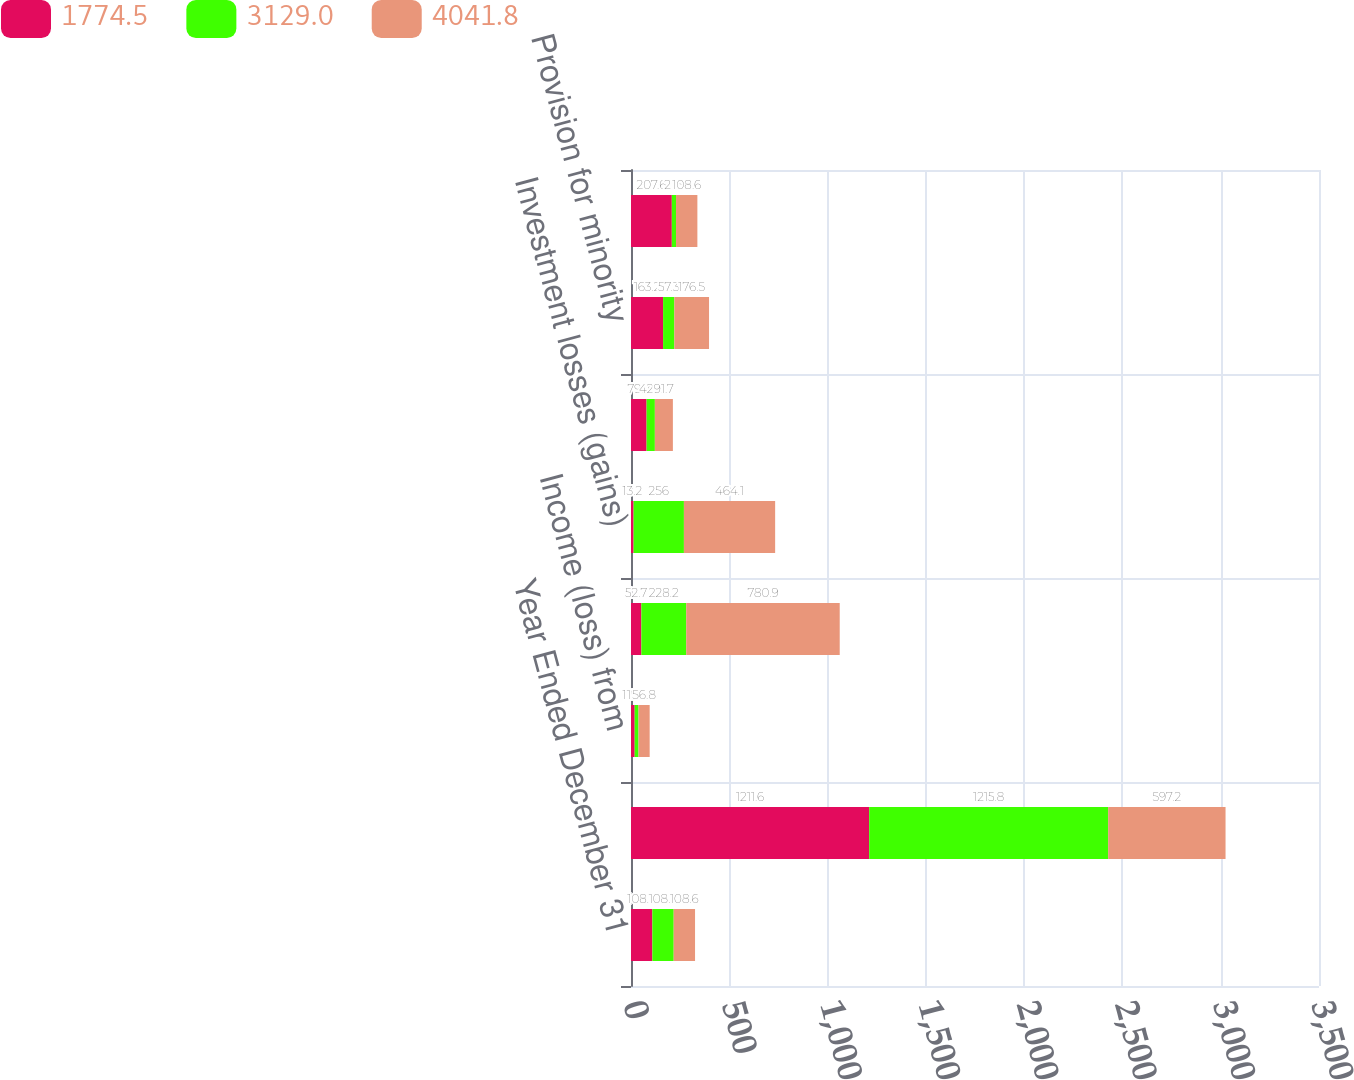Convert chart. <chart><loc_0><loc_0><loc_500><loc_500><stacked_bar_chart><ecel><fcel>Year Ended December 31<fcel>Net income (loss)<fcel>Income (loss) from<fcel>Provision for doubtful<fcel>Investment losses (gains)<fcel>Undistributed earnings<fcel>Provision for minority<fcel>Amortization of investments<nl><fcel>1774.5<fcel>108.6<fcel>1211.6<fcel>18.7<fcel>52.7<fcel>13.2<fcel>79.2<fcel>163.2<fcel>207.6<nl><fcel>3129<fcel>108.6<fcel>1215.8<fcel>19.5<fcel>228.2<fcel>256<fcel>42.2<fcel>57.3<fcel>21.5<nl><fcel>4041.8<fcel>108.6<fcel>597.2<fcel>56.8<fcel>780.9<fcel>464.1<fcel>91.7<fcel>176.5<fcel>108.6<nl></chart> 